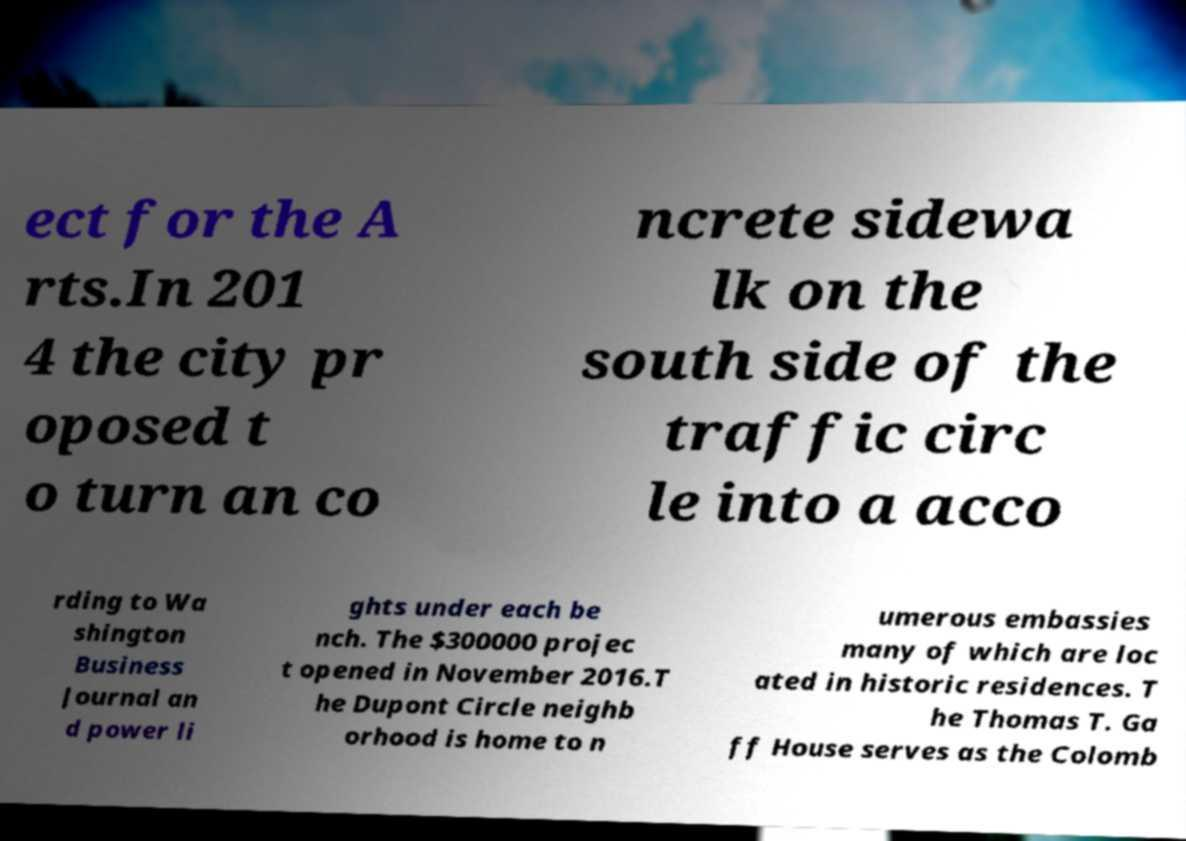I need the written content from this picture converted into text. Can you do that? ect for the A rts.In 201 4 the city pr oposed t o turn an co ncrete sidewa lk on the south side of the traffic circ le into a acco rding to Wa shington Business Journal an d power li ghts under each be nch. The $300000 projec t opened in November 2016.T he Dupont Circle neighb orhood is home to n umerous embassies many of which are loc ated in historic residences. T he Thomas T. Ga ff House serves as the Colomb 